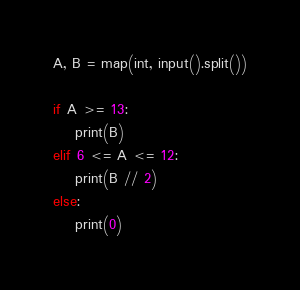<code> <loc_0><loc_0><loc_500><loc_500><_Python_>A, B = map(int, input().split())

if A >= 13:
    print(B)
elif 6 <= A <= 12:
    print(B // 2)
else:
    print(0)
</code> 